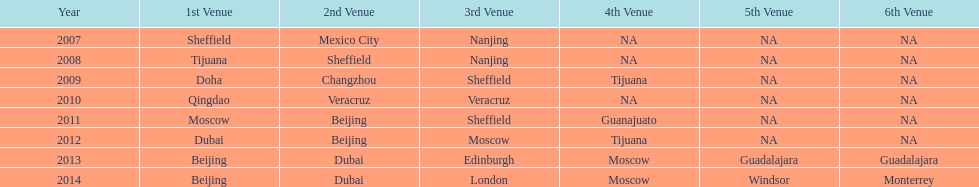What was the last year where tijuana was a venue? 2012. 